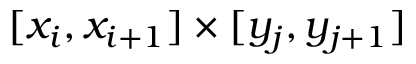<formula> <loc_0><loc_0><loc_500><loc_500>[ x _ { i } , x _ { i + 1 } ] \times [ y _ { j } , y _ { j + 1 } ]</formula> 